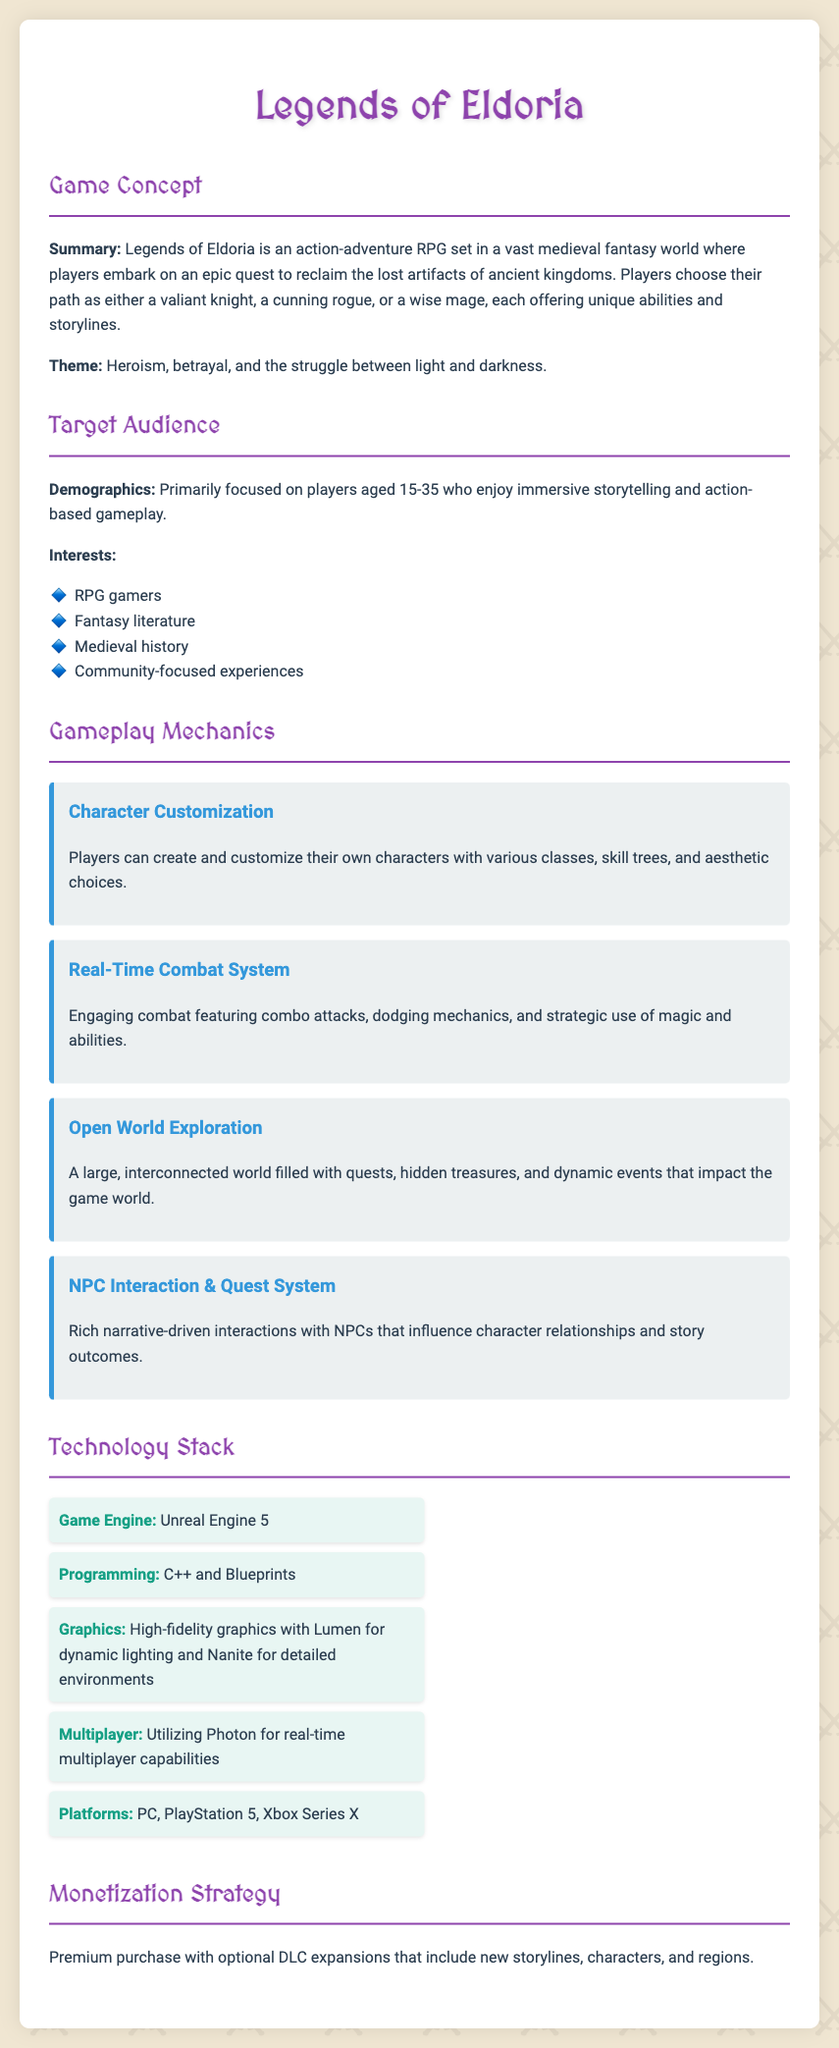What is the title of the game? The title of the game is specified at the beginning of the document.
Answer: Legends of Eldoria What is the primary theme of the game? The theme is highlighted in the Game Concept section.
Answer: Heroism, betrayal, and the struggle between light and darkness What age group is the target audience? The demographics of the target audience is mentioned in the Target Audience section.
Answer: 15-35 Which game engine will be used? The Technology Stack section lists the game engine.
Answer: Unreal Engine 5 What gameplay feature allows character customization? The Gameplay Mechanics section describes a specific feature for customization.
Answer: Character Customization What type of combat system is employed? The gameplay mechanic related to combat is outlined in the document.
Answer: Real-Time Combat System What platforms will the game be available on? The platforms are mentioned in the Technology Stack section.
Answer: PC, PlayStation 5, Xbox Series X What is the monetization strategy? The strategy for monetization is detailed towards the end of the document.
Answer: Premium purchase with optional DLC expansions What kind of world will players explore? The type of exploration is defined in the Gameplay Mechanics section.
Answer: Open World Exploration 